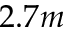Convert formula to latex. <formula><loc_0><loc_0><loc_500><loc_500>2 . 7 m</formula> 